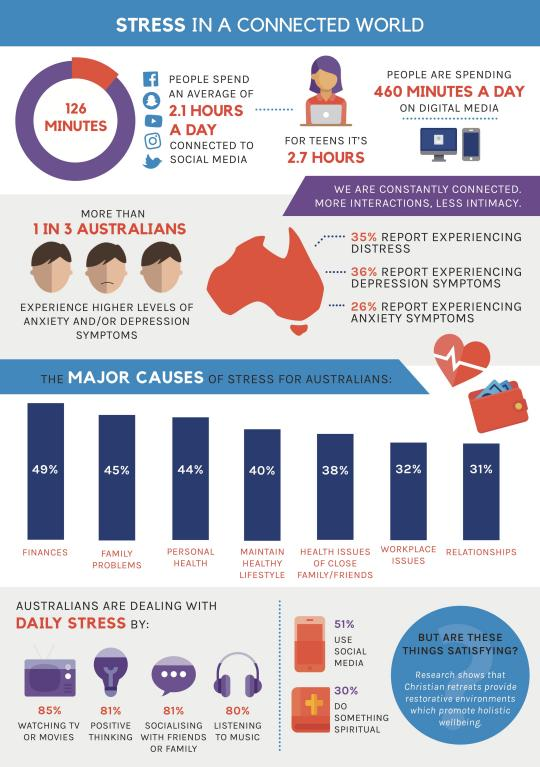Highlight a few significant elements in this photo. According to a survey conducted in Australia, 31% of the population reported that relationships were the major cause of their stress. Finances are the major cause of stress among Australians. According to a survey conducted in Australia, 81% of the population deals with daily stress through positive thinking. According to a recent study, the average Australian spends approximately 126 minutes per day on social media. According to a survey, 44% of Australians believed that their personal health was the primary cause of stress in their lives. 